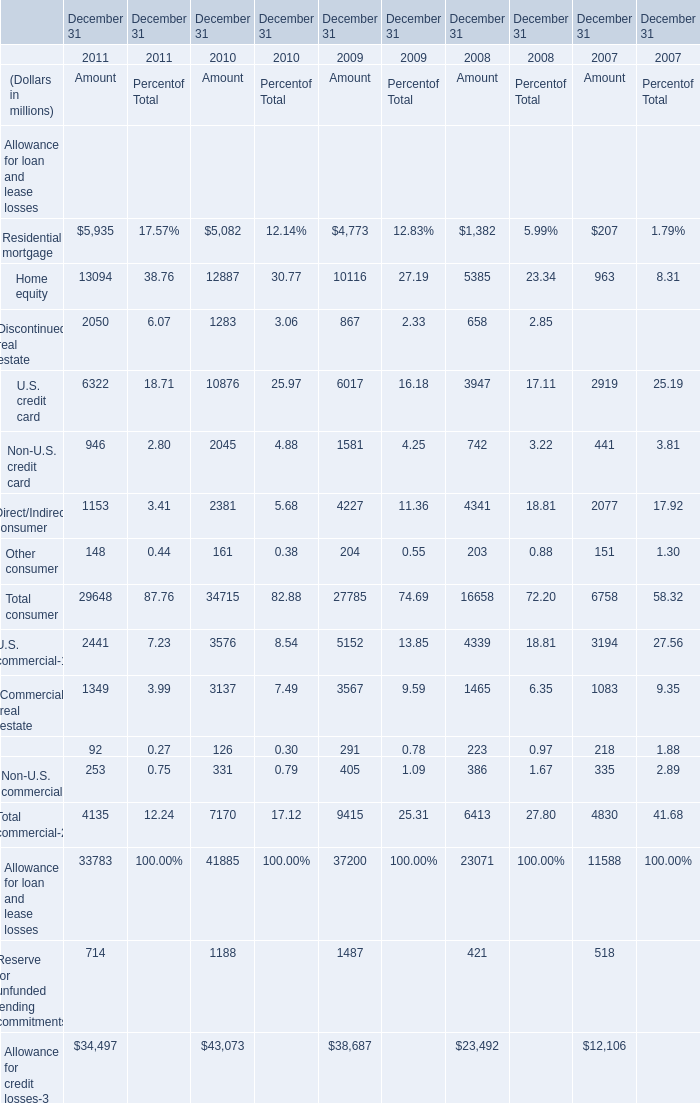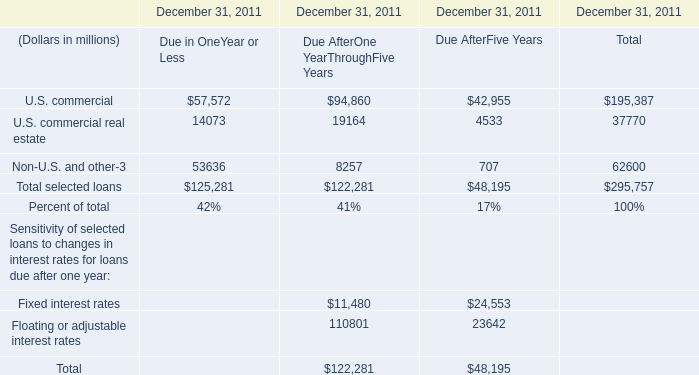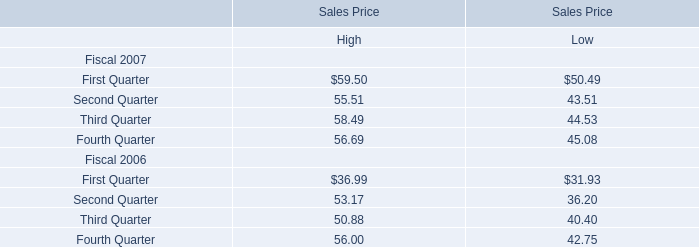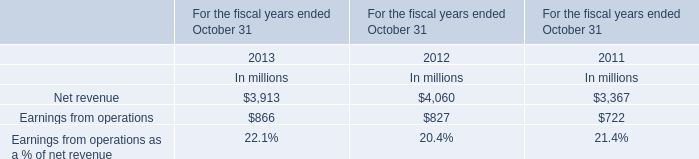What is the growing rate of Commercial real estate in the years with the least Other consumer? 
Computations: (1349 / (((3137 + 3567) + 1465) + 1083))
Answer: 0.14581. 